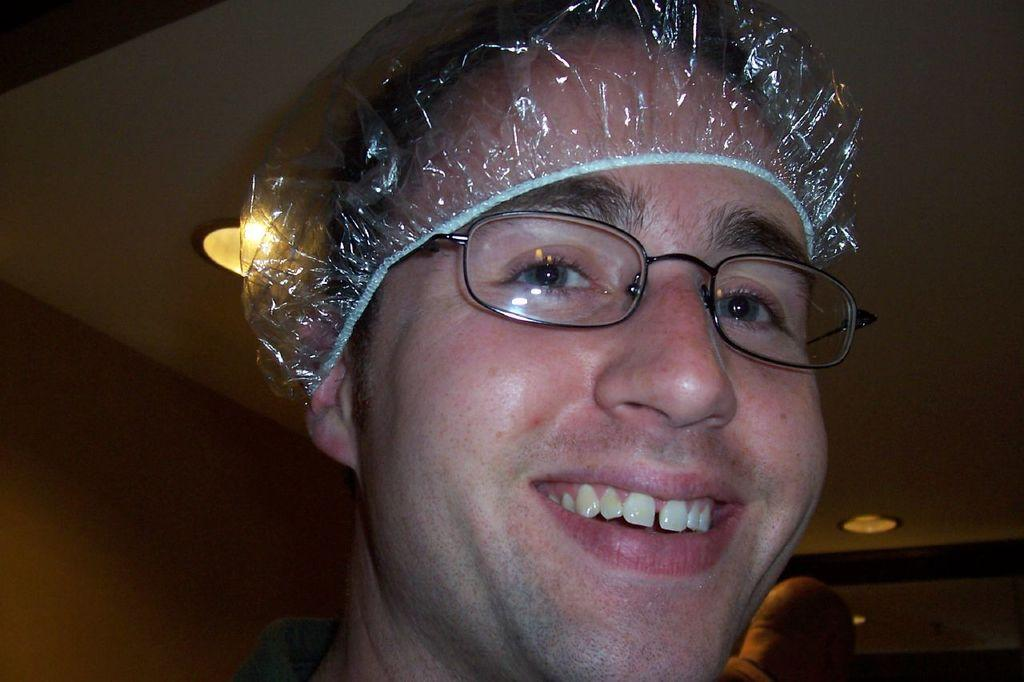How many people are in the image? There are two persons in the image. What is covering the head of one of the persons? One of the persons is wearing a cover on their head. What can be seen above the people in the image? There is a ceiling visible in the image. What type of illumination is present in the image? There are lights in the image. What type of jelly is being used as a decoration in the image? There is no jelly present in the image. What scent can be detected in the image? The image does not provide any information about scents. 